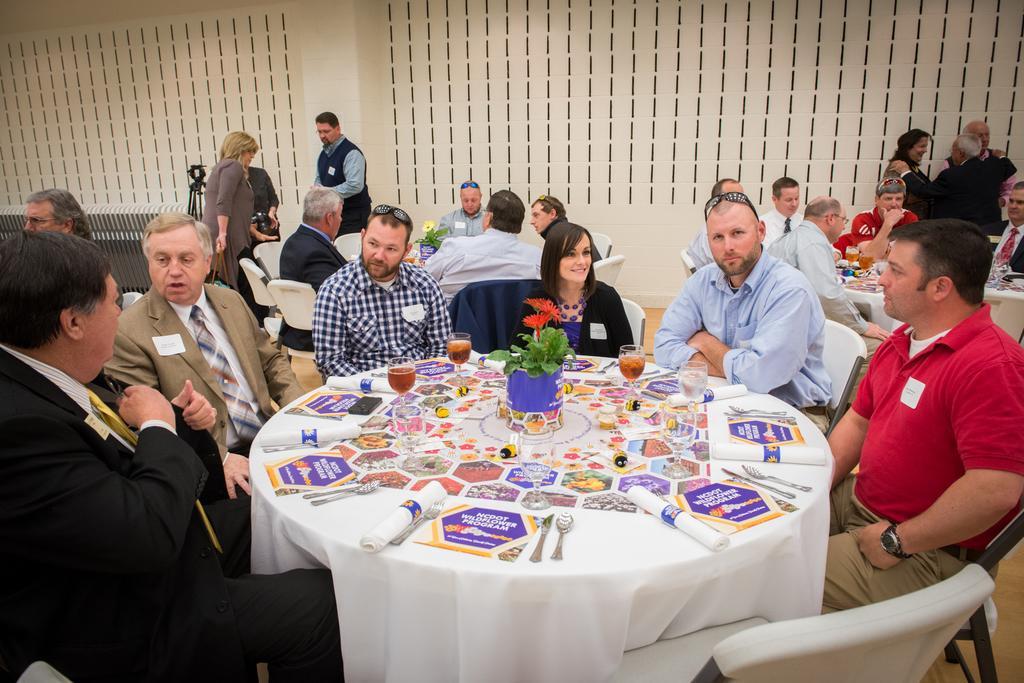Describe this image in one or two sentences. People are sitting in groups around tables and discussing among themselves. 